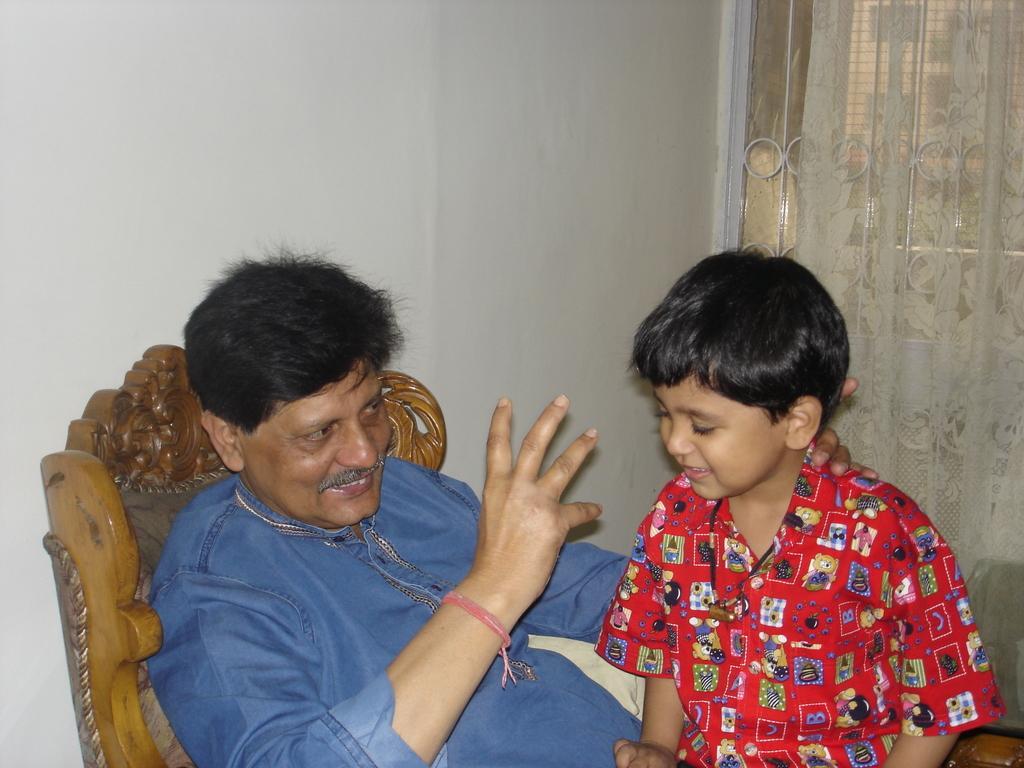Could you give a brief overview of what you see in this image? In this image there is a kid sitting on a person's lap. The person is sitting on a chair, behind him there is a wall, beside him there are curtains on the grill window. 